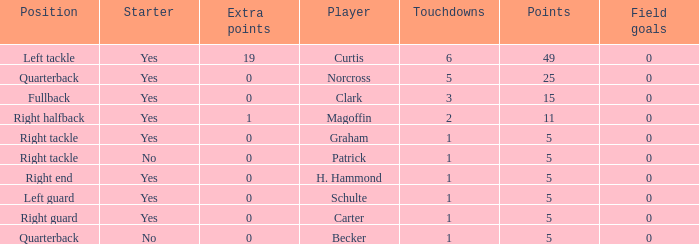Name the most touchdowns for becker  1.0. 